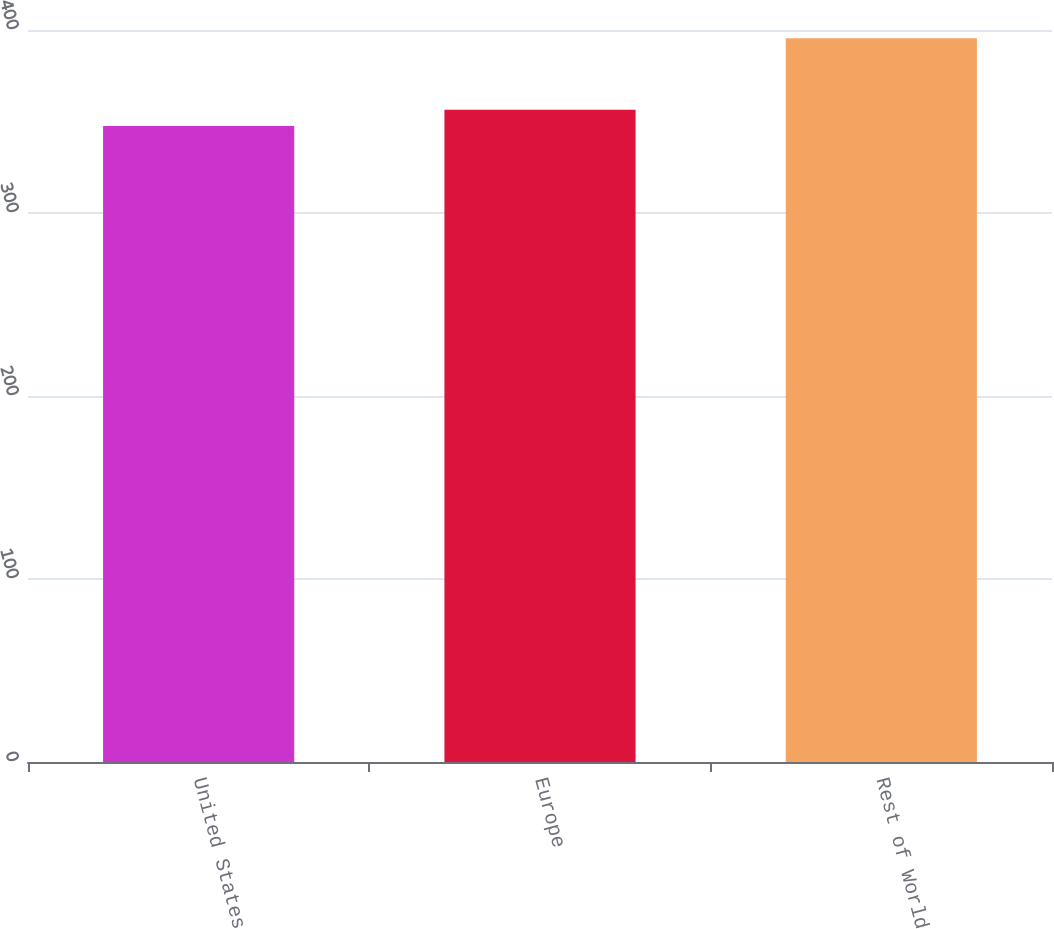<chart> <loc_0><loc_0><loc_500><loc_500><bar_chart><fcel>United States<fcel>Europe<fcel>Rest of World<nl><fcel>347.6<fcel>356.4<fcel>395.5<nl></chart> 